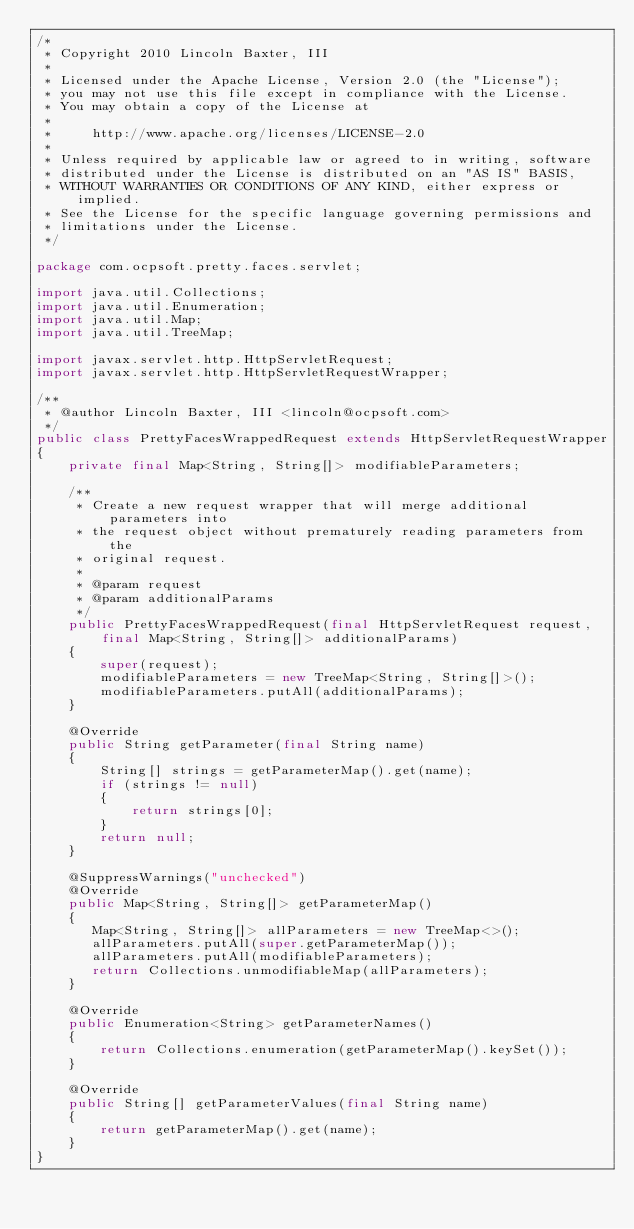Convert code to text. <code><loc_0><loc_0><loc_500><loc_500><_Java_>/*
 * Copyright 2010 Lincoln Baxter, III
 * 
 * Licensed under the Apache License, Version 2.0 (the "License");
 * you may not use this file except in compliance with the License.
 * You may obtain a copy of the License at
 * 
 *     http://www.apache.org/licenses/LICENSE-2.0
 * 
 * Unless required by applicable law or agreed to in writing, software
 * distributed under the License is distributed on an "AS IS" BASIS,
 * WITHOUT WARRANTIES OR CONDITIONS OF ANY KIND, either express or implied.
 * See the License for the specific language governing permissions and
 * limitations under the License.
 */

package com.ocpsoft.pretty.faces.servlet;

import java.util.Collections;
import java.util.Enumeration;
import java.util.Map;
import java.util.TreeMap;

import javax.servlet.http.HttpServletRequest;
import javax.servlet.http.HttpServletRequestWrapper;

/**
 * @author Lincoln Baxter, III <lincoln@ocpsoft.com>
 */
public class PrettyFacesWrappedRequest extends HttpServletRequestWrapper
{
    private final Map<String, String[]> modifiableParameters;

    /**
     * Create a new request wrapper that will merge additional parameters into
     * the request object without prematurely reading parameters from the
     * original request.
     * 
     * @param request
     * @param additionalParams
     */
    public PrettyFacesWrappedRequest(final HttpServletRequest request, final Map<String, String[]> additionalParams)
    {
        super(request);
        modifiableParameters = new TreeMap<String, String[]>();
        modifiableParameters.putAll(additionalParams);
    }

    @Override
    public String getParameter(final String name)
    {
        String[] strings = getParameterMap().get(name);
        if (strings != null)
        {
            return strings[0];
        }
        return null;
    }

    @SuppressWarnings("unchecked")
    @Override
    public Map<String, String[]> getParameterMap()
    {
       Map<String, String[]> allParameters = new TreeMap<>();
       allParameters.putAll(super.getParameterMap());
       allParameters.putAll(modifiableParameters);
       return Collections.unmodifiableMap(allParameters);
    }

    @Override
    public Enumeration<String> getParameterNames()
    {
        return Collections.enumeration(getParameterMap().keySet());
    }

    @Override
    public String[] getParameterValues(final String name)
    {
        return getParameterMap().get(name);
    }
}
</code> 